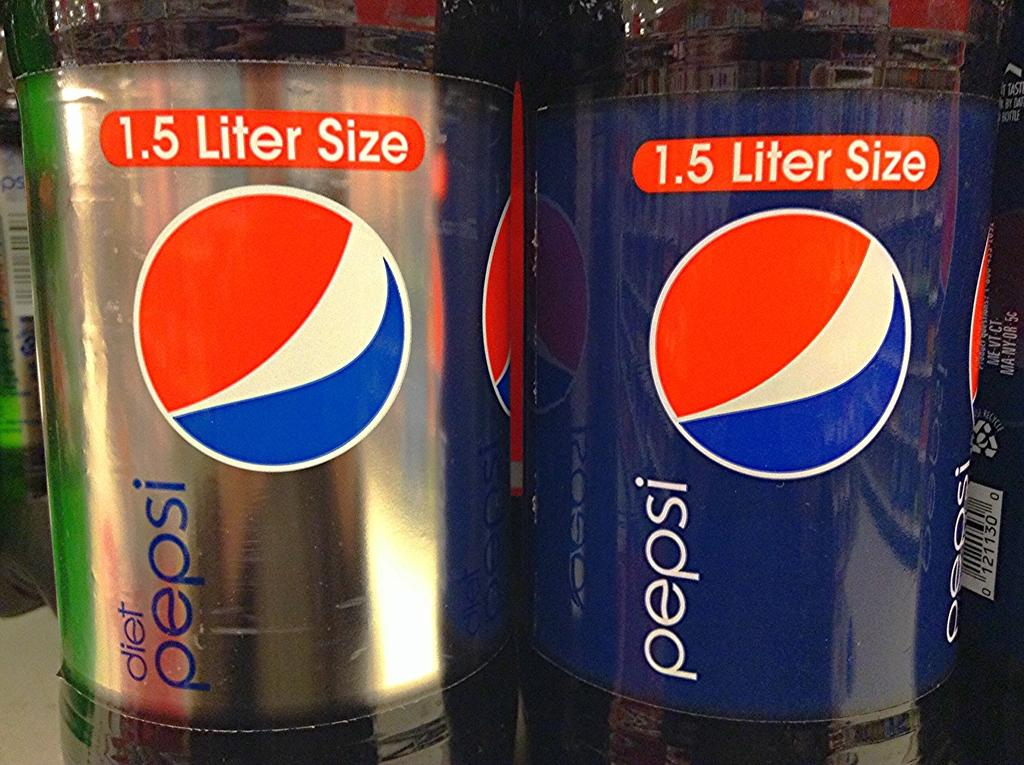Provide a one-sentence caption for the provided image. A diet Pepsi and regular Pepsi sit next to each other on a shelf. 